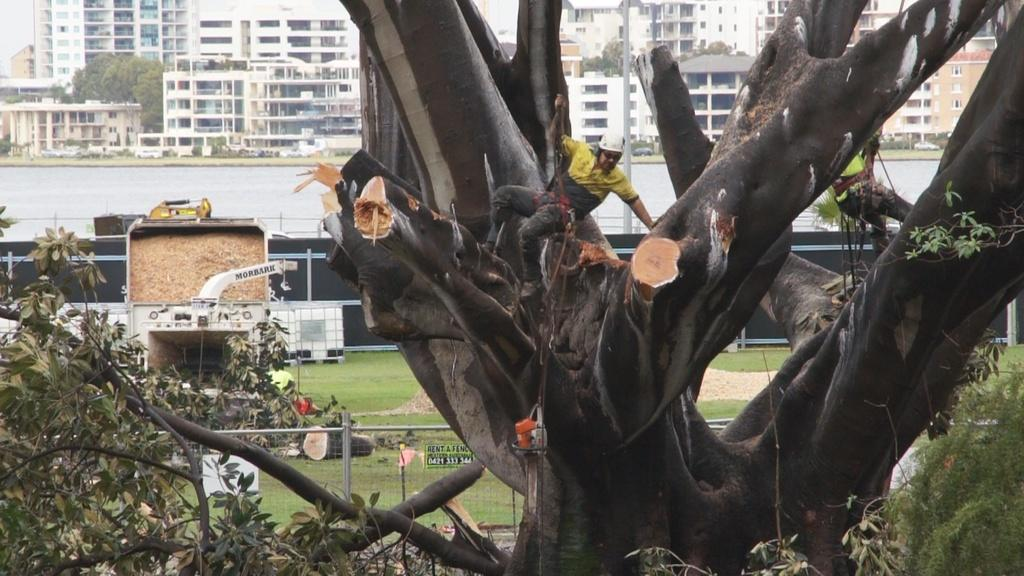What is located in the center of the image? There are trees in the center of the image. What type of structure can be seen in the image? There is a fence in the image. What can be seen in the distance in the image? There are buildings and poles in the background of the image. How many slaves are visible in the image? There are no slaves present in the image. What type of farm can be seen in the image? There is no farm present in the image. 